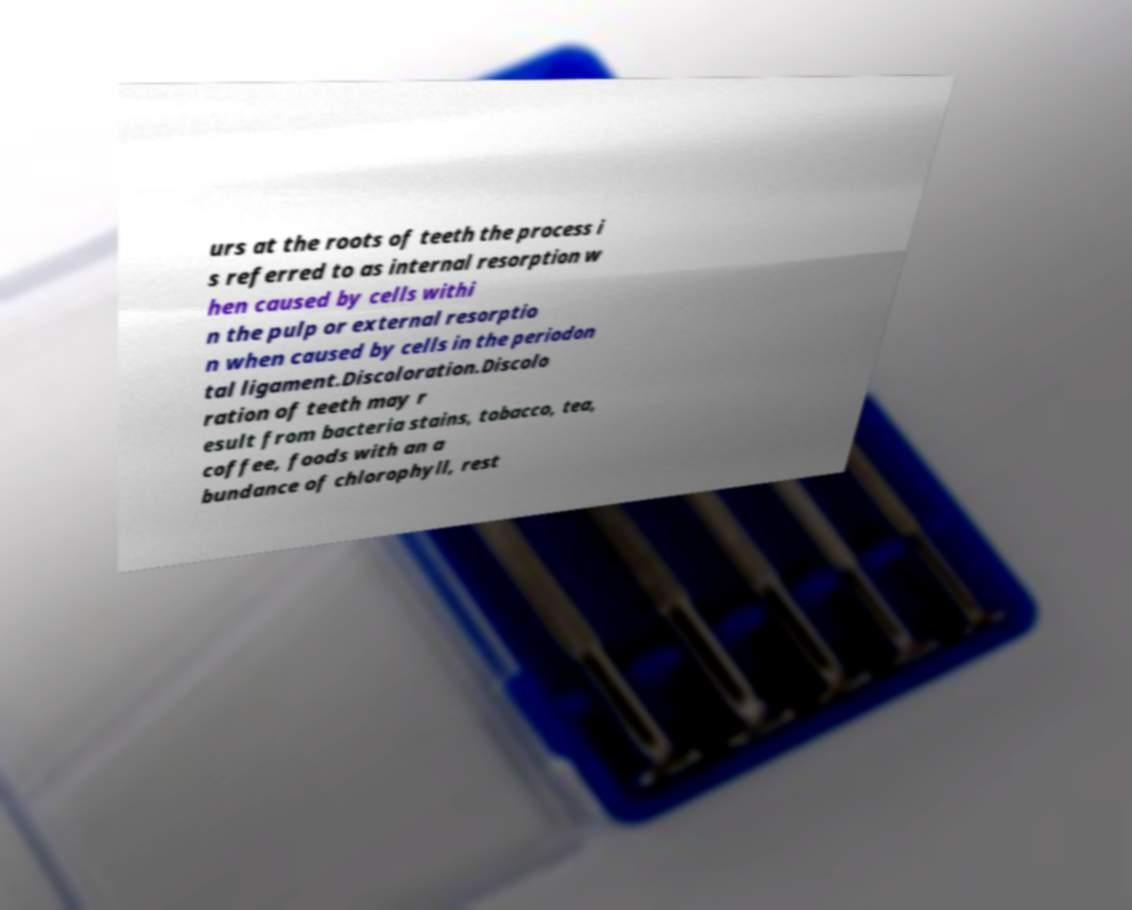For documentation purposes, I need the text within this image transcribed. Could you provide that? urs at the roots of teeth the process i s referred to as internal resorption w hen caused by cells withi n the pulp or external resorptio n when caused by cells in the periodon tal ligament.Discoloration.Discolo ration of teeth may r esult from bacteria stains, tobacco, tea, coffee, foods with an a bundance of chlorophyll, rest 